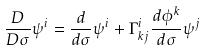Convert formula to latex. <formula><loc_0><loc_0><loc_500><loc_500>\frac { D } { D \sigma } \psi ^ { i } = \frac { d } { d \sigma } \psi ^ { i } + \Gamma ^ { i } _ { k j } \frac { d \phi ^ { k } } { d \sigma } \psi ^ { j }</formula> 